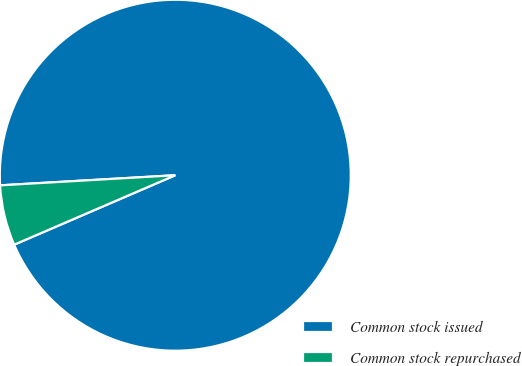Convert chart. <chart><loc_0><loc_0><loc_500><loc_500><pie_chart><fcel>Common stock issued<fcel>Common stock repurchased<nl><fcel>94.44%<fcel>5.56%<nl></chart> 